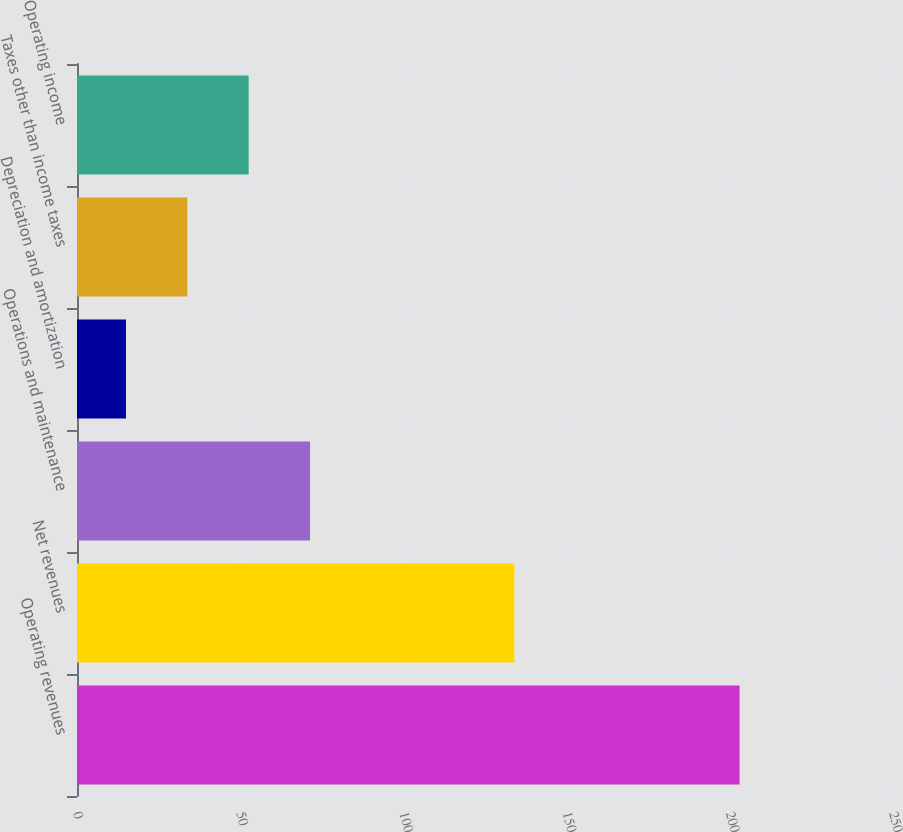<chart> <loc_0><loc_0><loc_500><loc_500><bar_chart><fcel>Operating revenues<fcel>Net revenues<fcel>Operations and maintenance<fcel>Depreciation and amortization<fcel>Taxes other than income taxes<fcel>Operating income<nl><fcel>203<fcel>134<fcel>71.4<fcel>15<fcel>33.8<fcel>52.6<nl></chart> 